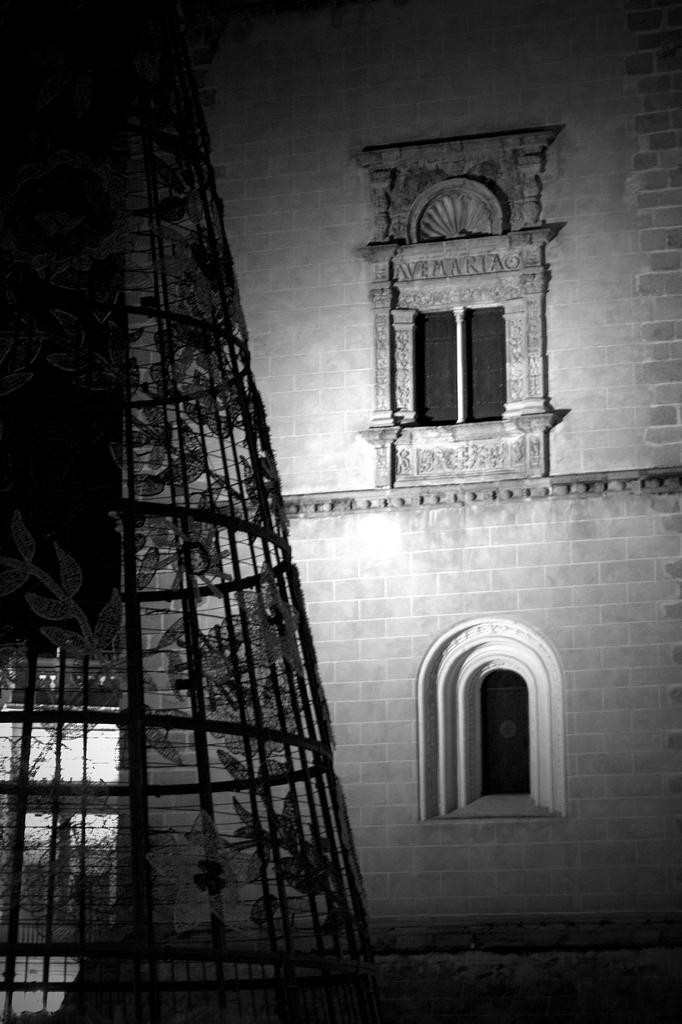What is the main structure visible in the image? There is a building in the image. How many windows can be seen on the building? The building has two windows. What type of appliance is your mom using on the roof in the image? There is no information about a mom, an appliance, or a roof in the image. 